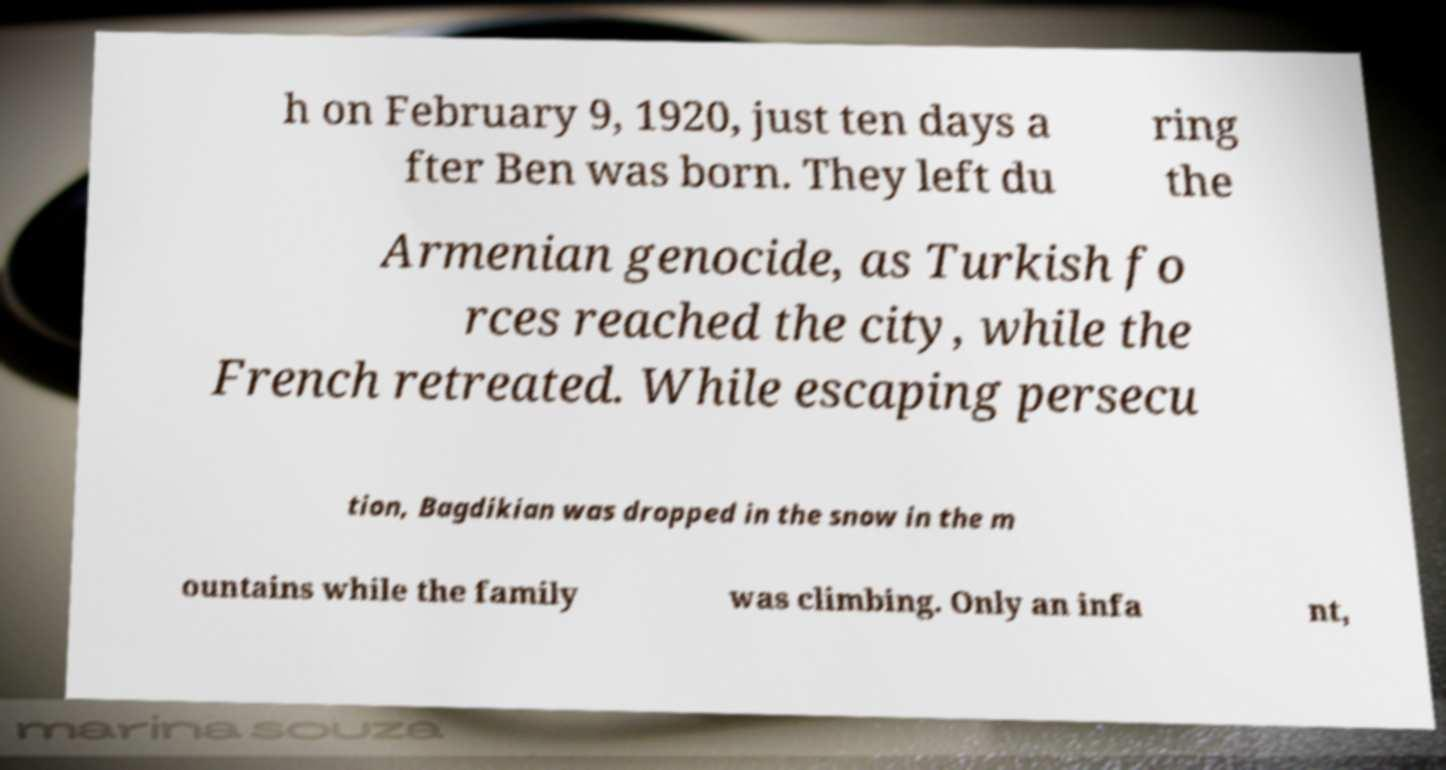Can you accurately transcribe the text from the provided image for me? h on February 9, 1920, just ten days a fter Ben was born. They left du ring the Armenian genocide, as Turkish fo rces reached the city, while the French retreated. While escaping persecu tion, Bagdikian was dropped in the snow in the m ountains while the family was climbing. Only an infa nt, 